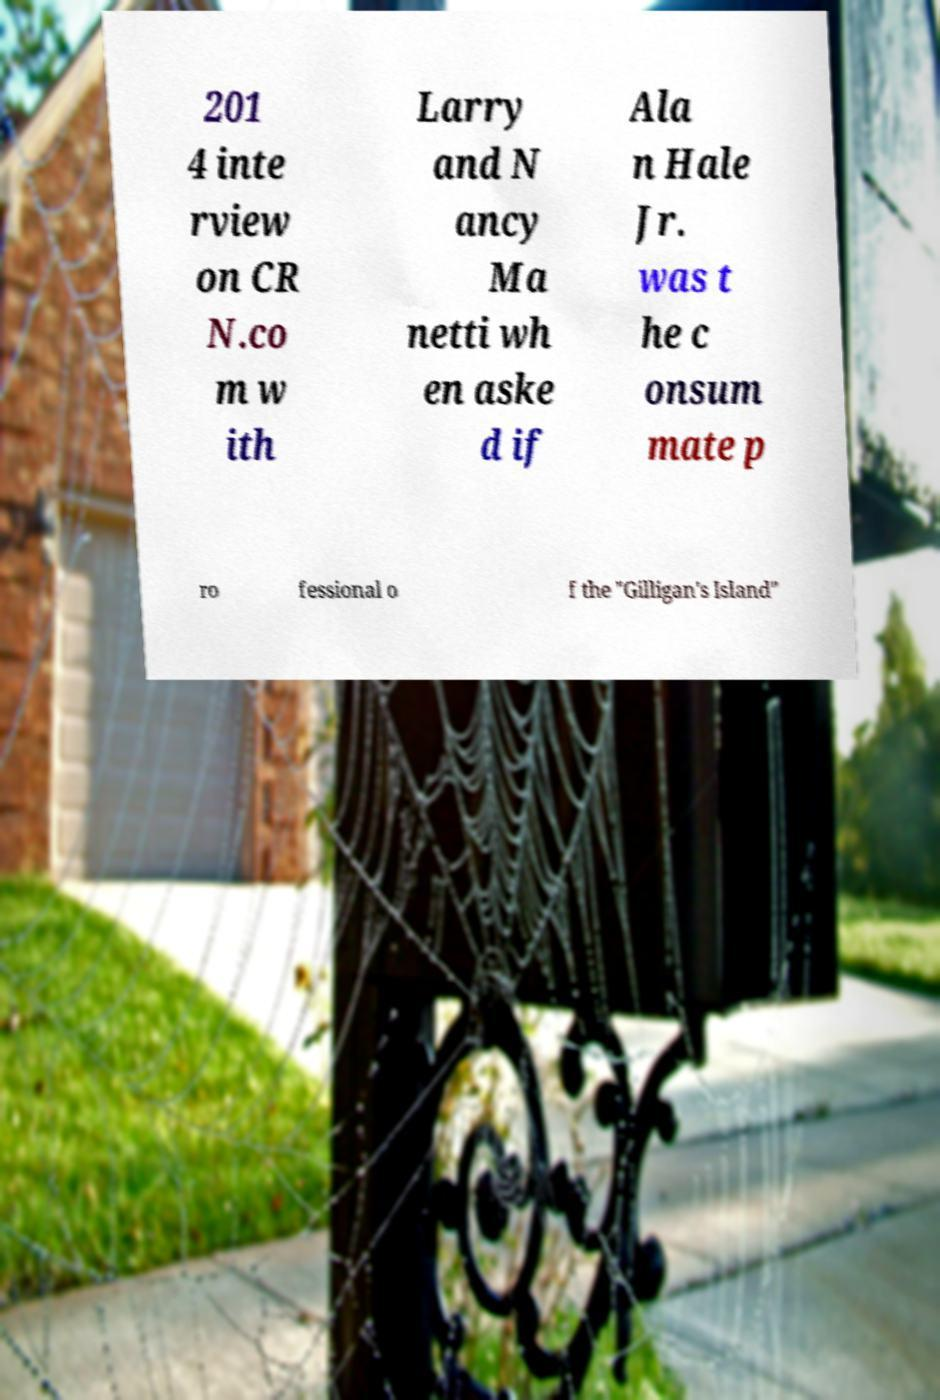Can you accurately transcribe the text from the provided image for me? 201 4 inte rview on CR N.co m w ith Larry and N ancy Ma netti wh en aske d if Ala n Hale Jr. was t he c onsum mate p ro fessional o f the "Gilligan's Island" 